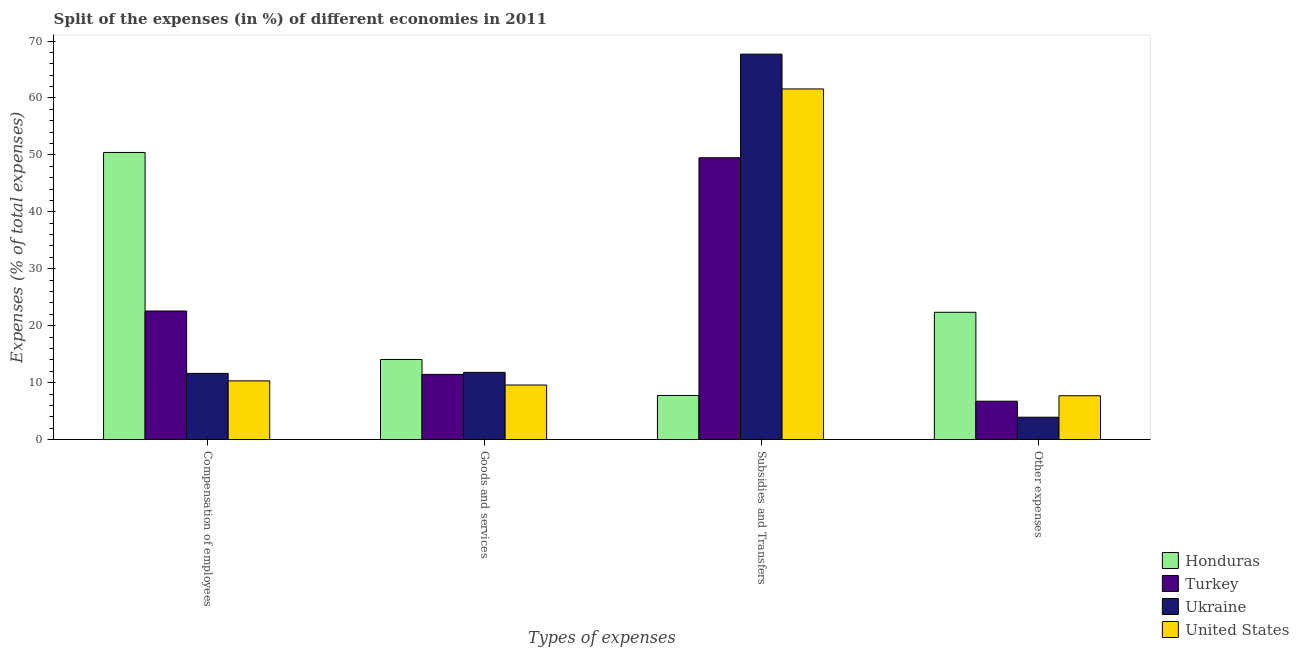How many different coloured bars are there?
Keep it short and to the point. 4. How many groups of bars are there?
Your answer should be very brief. 4. Are the number of bars on each tick of the X-axis equal?
Your answer should be very brief. Yes. How many bars are there on the 3rd tick from the left?
Ensure brevity in your answer.  4. What is the label of the 3rd group of bars from the left?
Keep it short and to the point. Subsidies and Transfers. What is the percentage of amount spent on subsidies in Turkey?
Provide a succinct answer. 49.5. Across all countries, what is the maximum percentage of amount spent on goods and services?
Offer a terse response. 14.07. Across all countries, what is the minimum percentage of amount spent on other expenses?
Offer a very short reply. 3.93. In which country was the percentage of amount spent on compensation of employees maximum?
Your answer should be compact. Honduras. In which country was the percentage of amount spent on compensation of employees minimum?
Provide a short and direct response. United States. What is the total percentage of amount spent on goods and services in the graph?
Provide a succinct answer. 46.92. What is the difference between the percentage of amount spent on goods and services in Ukraine and that in Turkey?
Offer a terse response. 0.36. What is the difference between the percentage of amount spent on compensation of employees in Honduras and the percentage of amount spent on other expenses in Ukraine?
Your answer should be very brief. 46.5. What is the average percentage of amount spent on goods and services per country?
Keep it short and to the point. 11.73. What is the difference between the percentage of amount spent on goods and services and percentage of amount spent on subsidies in Turkey?
Offer a very short reply. -38.04. What is the ratio of the percentage of amount spent on other expenses in Turkey to that in Ukraine?
Give a very brief answer. 1.71. Is the percentage of amount spent on compensation of employees in United States less than that in Honduras?
Offer a very short reply. Yes. Is the difference between the percentage of amount spent on compensation of employees in Honduras and United States greater than the difference between the percentage of amount spent on other expenses in Honduras and United States?
Give a very brief answer. Yes. What is the difference between the highest and the second highest percentage of amount spent on compensation of employees?
Provide a short and direct response. 27.84. What is the difference between the highest and the lowest percentage of amount spent on compensation of employees?
Give a very brief answer. 40.11. In how many countries, is the percentage of amount spent on goods and services greater than the average percentage of amount spent on goods and services taken over all countries?
Provide a short and direct response. 2. Is the sum of the percentage of amount spent on goods and services in Turkey and United States greater than the maximum percentage of amount spent on compensation of employees across all countries?
Make the answer very short. No. Is it the case that in every country, the sum of the percentage of amount spent on compensation of employees and percentage of amount spent on goods and services is greater than the sum of percentage of amount spent on other expenses and percentage of amount spent on subsidies?
Give a very brief answer. No. What does the 1st bar from the left in Compensation of employees represents?
Offer a very short reply. Honduras. Is it the case that in every country, the sum of the percentage of amount spent on compensation of employees and percentage of amount spent on goods and services is greater than the percentage of amount spent on subsidies?
Your answer should be compact. No. Are all the bars in the graph horizontal?
Your answer should be very brief. No. Does the graph contain grids?
Your answer should be compact. No. How many legend labels are there?
Make the answer very short. 4. How are the legend labels stacked?
Provide a succinct answer. Vertical. What is the title of the graph?
Give a very brief answer. Split of the expenses (in %) of different economies in 2011. What is the label or title of the X-axis?
Offer a very short reply. Types of expenses. What is the label or title of the Y-axis?
Ensure brevity in your answer.  Expenses (% of total expenses). What is the Expenses (% of total expenses) of Honduras in Compensation of employees?
Provide a succinct answer. 50.43. What is the Expenses (% of total expenses) of Turkey in Compensation of employees?
Offer a very short reply. 22.58. What is the Expenses (% of total expenses) in Ukraine in Compensation of employees?
Keep it short and to the point. 11.63. What is the Expenses (% of total expenses) of United States in Compensation of employees?
Make the answer very short. 10.31. What is the Expenses (% of total expenses) of Honduras in Goods and services?
Offer a terse response. 14.07. What is the Expenses (% of total expenses) in Turkey in Goods and services?
Keep it short and to the point. 11.45. What is the Expenses (% of total expenses) of Ukraine in Goods and services?
Provide a short and direct response. 11.81. What is the Expenses (% of total expenses) in United States in Goods and services?
Provide a short and direct response. 9.59. What is the Expenses (% of total expenses) of Honduras in Subsidies and Transfers?
Your response must be concise. 7.75. What is the Expenses (% of total expenses) in Turkey in Subsidies and Transfers?
Provide a short and direct response. 49.5. What is the Expenses (% of total expenses) of Ukraine in Subsidies and Transfers?
Provide a short and direct response. 67.69. What is the Expenses (% of total expenses) in United States in Subsidies and Transfers?
Make the answer very short. 61.58. What is the Expenses (% of total expenses) of Honduras in Other expenses?
Ensure brevity in your answer.  22.36. What is the Expenses (% of total expenses) of Turkey in Other expenses?
Ensure brevity in your answer.  6.74. What is the Expenses (% of total expenses) in Ukraine in Other expenses?
Keep it short and to the point. 3.93. What is the Expenses (% of total expenses) of United States in Other expenses?
Offer a very short reply. 7.7. Across all Types of expenses, what is the maximum Expenses (% of total expenses) in Honduras?
Ensure brevity in your answer.  50.43. Across all Types of expenses, what is the maximum Expenses (% of total expenses) in Turkey?
Your response must be concise. 49.5. Across all Types of expenses, what is the maximum Expenses (% of total expenses) of Ukraine?
Keep it short and to the point. 67.69. Across all Types of expenses, what is the maximum Expenses (% of total expenses) in United States?
Give a very brief answer. 61.58. Across all Types of expenses, what is the minimum Expenses (% of total expenses) of Honduras?
Provide a short and direct response. 7.75. Across all Types of expenses, what is the minimum Expenses (% of total expenses) in Turkey?
Give a very brief answer. 6.74. Across all Types of expenses, what is the minimum Expenses (% of total expenses) of Ukraine?
Provide a succinct answer. 3.93. Across all Types of expenses, what is the minimum Expenses (% of total expenses) of United States?
Provide a short and direct response. 7.7. What is the total Expenses (% of total expenses) of Honduras in the graph?
Make the answer very short. 94.61. What is the total Expenses (% of total expenses) of Turkey in the graph?
Offer a terse response. 90.28. What is the total Expenses (% of total expenses) in Ukraine in the graph?
Give a very brief answer. 95.06. What is the total Expenses (% of total expenses) in United States in the graph?
Provide a succinct answer. 89.18. What is the difference between the Expenses (% of total expenses) of Honduras in Compensation of employees and that in Goods and services?
Provide a short and direct response. 36.36. What is the difference between the Expenses (% of total expenses) of Turkey in Compensation of employees and that in Goods and services?
Offer a terse response. 11.13. What is the difference between the Expenses (% of total expenses) of Ukraine in Compensation of employees and that in Goods and services?
Give a very brief answer. -0.18. What is the difference between the Expenses (% of total expenses) of United States in Compensation of employees and that in Goods and services?
Your answer should be compact. 0.72. What is the difference between the Expenses (% of total expenses) in Honduras in Compensation of employees and that in Subsidies and Transfers?
Your answer should be very brief. 42.68. What is the difference between the Expenses (% of total expenses) of Turkey in Compensation of employees and that in Subsidies and Transfers?
Your response must be concise. -26.91. What is the difference between the Expenses (% of total expenses) in Ukraine in Compensation of employees and that in Subsidies and Transfers?
Your response must be concise. -56.07. What is the difference between the Expenses (% of total expenses) in United States in Compensation of employees and that in Subsidies and Transfers?
Your answer should be very brief. -51.27. What is the difference between the Expenses (% of total expenses) of Honduras in Compensation of employees and that in Other expenses?
Keep it short and to the point. 28.07. What is the difference between the Expenses (% of total expenses) of Turkey in Compensation of employees and that in Other expenses?
Give a very brief answer. 15.84. What is the difference between the Expenses (% of total expenses) in Ukraine in Compensation of employees and that in Other expenses?
Provide a short and direct response. 7.69. What is the difference between the Expenses (% of total expenses) in United States in Compensation of employees and that in Other expenses?
Offer a very short reply. 2.62. What is the difference between the Expenses (% of total expenses) in Honduras in Goods and services and that in Subsidies and Transfers?
Offer a terse response. 6.32. What is the difference between the Expenses (% of total expenses) of Turkey in Goods and services and that in Subsidies and Transfers?
Your answer should be very brief. -38.04. What is the difference between the Expenses (% of total expenses) in Ukraine in Goods and services and that in Subsidies and Transfers?
Provide a short and direct response. -55.88. What is the difference between the Expenses (% of total expenses) in United States in Goods and services and that in Subsidies and Transfers?
Your answer should be compact. -51.99. What is the difference between the Expenses (% of total expenses) of Honduras in Goods and services and that in Other expenses?
Your answer should be very brief. -8.29. What is the difference between the Expenses (% of total expenses) in Turkey in Goods and services and that in Other expenses?
Your response must be concise. 4.71. What is the difference between the Expenses (% of total expenses) in Ukraine in Goods and services and that in Other expenses?
Your response must be concise. 7.88. What is the difference between the Expenses (% of total expenses) of United States in Goods and services and that in Other expenses?
Your answer should be very brief. 1.89. What is the difference between the Expenses (% of total expenses) in Honduras in Subsidies and Transfers and that in Other expenses?
Ensure brevity in your answer.  -14.61. What is the difference between the Expenses (% of total expenses) in Turkey in Subsidies and Transfers and that in Other expenses?
Offer a very short reply. 42.76. What is the difference between the Expenses (% of total expenses) of Ukraine in Subsidies and Transfers and that in Other expenses?
Provide a succinct answer. 63.76. What is the difference between the Expenses (% of total expenses) in United States in Subsidies and Transfers and that in Other expenses?
Provide a short and direct response. 53.88. What is the difference between the Expenses (% of total expenses) in Honduras in Compensation of employees and the Expenses (% of total expenses) in Turkey in Goods and services?
Your answer should be compact. 38.98. What is the difference between the Expenses (% of total expenses) in Honduras in Compensation of employees and the Expenses (% of total expenses) in Ukraine in Goods and services?
Offer a terse response. 38.62. What is the difference between the Expenses (% of total expenses) of Honduras in Compensation of employees and the Expenses (% of total expenses) of United States in Goods and services?
Ensure brevity in your answer.  40.84. What is the difference between the Expenses (% of total expenses) of Turkey in Compensation of employees and the Expenses (% of total expenses) of Ukraine in Goods and services?
Keep it short and to the point. 10.78. What is the difference between the Expenses (% of total expenses) of Turkey in Compensation of employees and the Expenses (% of total expenses) of United States in Goods and services?
Provide a succinct answer. 12.99. What is the difference between the Expenses (% of total expenses) in Ukraine in Compensation of employees and the Expenses (% of total expenses) in United States in Goods and services?
Provide a succinct answer. 2.04. What is the difference between the Expenses (% of total expenses) in Honduras in Compensation of employees and the Expenses (% of total expenses) in Turkey in Subsidies and Transfers?
Give a very brief answer. 0.93. What is the difference between the Expenses (% of total expenses) of Honduras in Compensation of employees and the Expenses (% of total expenses) of Ukraine in Subsidies and Transfers?
Provide a short and direct response. -17.26. What is the difference between the Expenses (% of total expenses) in Honduras in Compensation of employees and the Expenses (% of total expenses) in United States in Subsidies and Transfers?
Provide a short and direct response. -11.15. What is the difference between the Expenses (% of total expenses) in Turkey in Compensation of employees and the Expenses (% of total expenses) in Ukraine in Subsidies and Transfers?
Give a very brief answer. -45.11. What is the difference between the Expenses (% of total expenses) of Turkey in Compensation of employees and the Expenses (% of total expenses) of United States in Subsidies and Transfers?
Keep it short and to the point. -39. What is the difference between the Expenses (% of total expenses) in Ukraine in Compensation of employees and the Expenses (% of total expenses) in United States in Subsidies and Transfers?
Your response must be concise. -49.96. What is the difference between the Expenses (% of total expenses) in Honduras in Compensation of employees and the Expenses (% of total expenses) in Turkey in Other expenses?
Provide a succinct answer. 43.69. What is the difference between the Expenses (% of total expenses) of Honduras in Compensation of employees and the Expenses (% of total expenses) of Ukraine in Other expenses?
Provide a short and direct response. 46.5. What is the difference between the Expenses (% of total expenses) of Honduras in Compensation of employees and the Expenses (% of total expenses) of United States in Other expenses?
Your answer should be very brief. 42.73. What is the difference between the Expenses (% of total expenses) of Turkey in Compensation of employees and the Expenses (% of total expenses) of Ukraine in Other expenses?
Your answer should be compact. 18.65. What is the difference between the Expenses (% of total expenses) in Turkey in Compensation of employees and the Expenses (% of total expenses) in United States in Other expenses?
Provide a short and direct response. 14.88. What is the difference between the Expenses (% of total expenses) in Ukraine in Compensation of employees and the Expenses (% of total expenses) in United States in Other expenses?
Your answer should be very brief. 3.93. What is the difference between the Expenses (% of total expenses) of Honduras in Goods and services and the Expenses (% of total expenses) of Turkey in Subsidies and Transfers?
Offer a very short reply. -35.43. What is the difference between the Expenses (% of total expenses) of Honduras in Goods and services and the Expenses (% of total expenses) of Ukraine in Subsidies and Transfers?
Your answer should be very brief. -53.62. What is the difference between the Expenses (% of total expenses) in Honduras in Goods and services and the Expenses (% of total expenses) in United States in Subsidies and Transfers?
Offer a very short reply. -47.51. What is the difference between the Expenses (% of total expenses) of Turkey in Goods and services and the Expenses (% of total expenses) of Ukraine in Subsidies and Transfers?
Keep it short and to the point. -56.24. What is the difference between the Expenses (% of total expenses) of Turkey in Goods and services and the Expenses (% of total expenses) of United States in Subsidies and Transfers?
Offer a terse response. -50.13. What is the difference between the Expenses (% of total expenses) of Ukraine in Goods and services and the Expenses (% of total expenses) of United States in Subsidies and Transfers?
Provide a succinct answer. -49.77. What is the difference between the Expenses (% of total expenses) of Honduras in Goods and services and the Expenses (% of total expenses) of Turkey in Other expenses?
Offer a very short reply. 7.33. What is the difference between the Expenses (% of total expenses) of Honduras in Goods and services and the Expenses (% of total expenses) of Ukraine in Other expenses?
Ensure brevity in your answer.  10.14. What is the difference between the Expenses (% of total expenses) of Honduras in Goods and services and the Expenses (% of total expenses) of United States in Other expenses?
Offer a very short reply. 6.37. What is the difference between the Expenses (% of total expenses) of Turkey in Goods and services and the Expenses (% of total expenses) of Ukraine in Other expenses?
Your answer should be compact. 7.52. What is the difference between the Expenses (% of total expenses) of Turkey in Goods and services and the Expenses (% of total expenses) of United States in Other expenses?
Ensure brevity in your answer.  3.75. What is the difference between the Expenses (% of total expenses) of Ukraine in Goods and services and the Expenses (% of total expenses) of United States in Other expenses?
Your response must be concise. 4.11. What is the difference between the Expenses (% of total expenses) of Honduras in Subsidies and Transfers and the Expenses (% of total expenses) of Turkey in Other expenses?
Make the answer very short. 1.01. What is the difference between the Expenses (% of total expenses) of Honduras in Subsidies and Transfers and the Expenses (% of total expenses) of Ukraine in Other expenses?
Your answer should be compact. 3.82. What is the difference between the Expenses (% of total expenses) in Honduras in Subsidies and Transfers and the Expenses (% of total expenses) in United States in Other expenses?
Your answer should be very brief. 0.05. What is the difference between the Expenses (% of total expenses) of Turkey in Subsidies and Transfers and the Expenses (% of total expenses) of Ukraine in Other expenses?
Offer a terse response. 45.57. What is the difference between the Expenses (% of total expenses) of Turkey in Subsidies and Transfers and the Expenses (% of total expenses) of United States in Other expenses?
Your answer should be compact. 41.8. What is the difference between the Expenses (% of total expenses) of Ukraine in Subsidies and Transfers and the Expenses (% of total expenses) of United States in Other expenses?
Ensure brevity in your answer.  59.99. What is the average Expenses (% of total expenses) in Honduras per Types of expenses?
Provide a succinct answer. 23.65. What is the average Expenses (% of total expenses) in Turkey per Types of expenses?
Your response must be concise. 22.57. What is the average Expenses (% of total expenses) in Ukraine per Types of expenses?
Ensure brevity in your answer.  23.76. What is the average Expenses (% of total expenses) in United States per Types of expenses?
Provide a succinct answer. 22.3. What is the difference between the Expenses (% of total expenses) of Honduras and Expenses (% of total expenses) of Turkey in Compensation of employees?
Your answer should be very brief. 27.84. What is the difference between the Expenses (% of total expenses) in Honduras and Expenses (% of total expenses) in Ukraine in Compensation of employees?
Give a very brief answer. 38.8. What is the difference between the Expenses (% of total expenses) of Honduras and Expenses (% of total expenses) of United States in Compensation of employees?
Your response must be concise. 40.11. What is the difference between the Expenses (% of total expenses) of Turkey and Expenses (% of total expenses) of Ukraine in Compensation of employees?
Offer a terse response. 10.96. What is the difference between the Expenses (% of total expenses) of Turkey and Expenses (% of total expenses) of United States in Compensation of employees?
Offer a terse response. 12.27. What is the difference between the Expenses (% of total expenses) in Ukraine and Expenses (% of total expenses) in United States in Compensation of employees?
Give a very brief answer. 1.31. What is the difference between the Expenses (% of total expenses) of Honduras and Expenses (% of total expenses) of Turkey in Goods and services?
Offer a terse response. 2.62. What is the difference between the Expenses (% of total expenses) of Honduras and Expenses (% of total expenses) of Ukraine in Goods and services?
Offer a very short reply. 2.26. What is the difference between the Expenses (% of total expenses) in Honduras and Expenses (% of total expenses) in United States in Goods and services?
Provide a succinct answer. 4.48. What is the difference between the Expenses (% of total expenses) in Turkey and Expenses (% of total expenses) in Ukraine in Goods and services?
Your answer should be very brief. -0.36. What is the difference between the Expenses (% of total expenses) in Turkey and Expenses (% of total expenses) in United States in Goods and services?
Provide a succinct answer. 1.86. What is the difference between the Expenses (% of total expenses) in Ukraine and Expenses (% of total expenses) in United States in Goods and services?
Make the answer very short. 2.22. What is the difference between the Expenses (% of total expenses) in Honduras and Expenses (% of total expenses) in Turkey in Subsidies and Transfers?
Make the answer very short. -41.75. What is the difference between the Expenses (% of total expenses) of Honduras and Expenses (% of total expenses) of Ukraine in Subsidies and Transfers?
Keep it short and to the point. -59.94. What is the difference between the Expenses (% of total expenses) in Honduras and Expenses (% of total expenses) in United States in Subsidies and Transfers?
Offer a terse response. -53.83. What is the difference between the Expenses (% of total expenses) in Turkey and Expenses (% of total expenses) in Ukraine in Subsidies and Transfers?
Make the answer very short. -18.19. What is the difference between the Expenses (% of total expenses) of Turkey and Expenses (% of total expenses) of United States in Subsidies and Transfers?
Ensure brevity in your answer.  -12.08. What is the difference between the Expenses (% of total expenses) in Ukraine and Expenses (% of total expenses) in United States in Subsidies and Transfers?
Provide a succinct answer. 6.11. What is the difference between the Expenses (% of total expenses) in Honduras and Expenses (% of total expenses) in Turkey in Other expenses?
Give a very brief answer. 15.62. What is the difference between the Expenses (% of total expenses) in Honduras and Expenses (% of total expenses) in Ukraine in Other expenses?
Your answer should be very brief. 18.43. What is the difference between the Expenses (% of total expenses) in Honduras and Expenses (% of total expenses) in United States in Other expenses?
Offer a very short reply. 14.66. What is the difference between the Expenses (% of total expenses) of Turkey and Expenses (% of total expenses) of Ukraine in Other expenses?
Your response must be concise. 2.81. What is the difference between the Expenses (% of total expenses) of Turkey and Expenses (% of total expenses) of United States in Other expenses?
Offer a very short reply. -0.96. What is the difference between the Expenses (% of total expenses) of Ukraine and Expenses (% of total expenses) of United States in Other expenses?
Keep it short and to the point. -3.77. What is the ratio of the Expenses (% of total expenses) of Honduras in Compensation of employees to that in Goods and services?
Give a very brief answer. 3.58. What is the ratio of the Expenses (% of total expenses) in Turkey in Compensation of employees to that in Goods and services?
Provide a short and direct response. 1.97. What is the ratio of the Expenses (% of total expenses) in Ukraine in Compensation of employees to that in Goods and services?
Offer a terse response. 0.98. What is the ratio of the Expenses (% of total expenses) of United States in Compensation of employees to that in Goods and services?
Provide a succinct answer. 1.08. What is the ratio of the Expenses (% of total expenses) of Honduras in Compensation of employees to that in Subsidies and Transfers?
Provide a succinct answer. 6.51. What is the ratio of the Expenses (% of total expenses) of Turkey in Compensation of employees to that in Subsidies and Transfers?
Give a very brief answer. 0.46. What is the ratio of the Expenses (% of total expenses) of Ukraine in Compensation of employees to that in Subsidies and Transfers?
Your response must be concise. 0.17. What is the ratio of the Expenses (% of total expenses) of United States in Compensation of employees to that in Subsidies and Transfers?
Make the answer very short. 0.17. What is the ratio of the Expenses (% of total expenses) of Honduras in Compensation of employees to that in Other expenses?
Your response must be concise. 2.26. What is the ratio of the Expenses (% of total expenses) of Turkey in Compensation of employees to that in Other expenses?
Offer a terse response. 3.35. What is the ratio of the Expenses (% of total expenses) in Ukraine in Compensation of employees to that in Other expenses?
Your answer should be very brief. 2.96. What is the ratio of the Expenses (% of total expenses) of United States in Compensation of employees to that in Other expenses?
Your answer should be very brief. 1.34. What is the ratio of the Expenses (% of total expenses) of Honduras in Goods and services to that in Subsidies and Transfers?
Keep it short and to the point. 1.82. What is the ratio of the Expenses (% of total expenses) of Turkey in Goods and services to that in Subsidies and Transfers?
Your answer should be very brief. 0.23. What is the ratio of the Expenses (% of total expenses) in Ukraine in Goods and services to that in Subsidies and Transfers?
Your answer should be very brief. 0.17. What is the ratio of the Expenses (% of total expenses) of United States in Goods and services to that in Subsidies and Transfers?
Keep it short and to the point. 0.16. What is the ratio of the Expenses (% of total expenses) in Honduras in Goods and services to that in Other expenses?
Provide a succinct answer. 0.63. What is the ratio of the Expenses (% of total expenses) in Turkey in Goods and services to that in Other expenses?
Your answer should be compact. 1.7. What is the ratio of the Expenses (% of total expenses) in Ukraine in Goods and services to that in Other expenses?
Your answer should be compact. 3. What is the ratio of the Expenses (% of total expenses) in United States in Goods and services to that in Other expenses?
Make the answer very short. 1.25. What is the ratio of the Expenses (% of total expenses) of Honduras in Subsidies and Transfers to that in Other expenses?
Offer a very short reply. 0.35. What is the ratio of the Expenses (% of total expenses) of Turkey in Subsidies and Transfers to that in Other expenses?
Offer a very short reply. 7.34. What is the ratio of the Expenses (% of total expenses) of Ukraine in Subsidies and Transfers to that in Other expenses?
Offer a very short reply. 17.22. What is the ratio of the Expenses (% of total expenses) of United States in Subsidies and Transfers to that in Other expenses?
Make the answer very short. 8. What is the difference between the highest and the second highest Expenses (% of total expenses) of Honduras?
Your answer should be very brief. 28.07. What is the difference between the highest and the second highest Expenses (% of total expenses) in Turkey?
Your answer should be very brief. 26.91. What is the difference between the highest and the second highest Expenses (% of total expenses) of Ukraine?
Keep it short and to the point. 55.88. What is the difference between the highest and the second highest Expenses (% of total expenses) of United States?
Keep it short and to the point. 51.27. What is the difference between the highest and the lowest Expenses (% of total expenses) in Honduras?
Ensure brevity in your answer.  42.68. What is the difference between the highest and the lowest Expenses (% of total expenses) in Turkey?
Your response must be concise. 42.76. What is the difference between the highest and the lowest Expenses (% of total expenses) in Ukraine?
Offer a terse response. 63.76. What is the difference between the highest and the lowest Expenses (% of total expenses) of United States?
Your response must be concise. 53.88. 